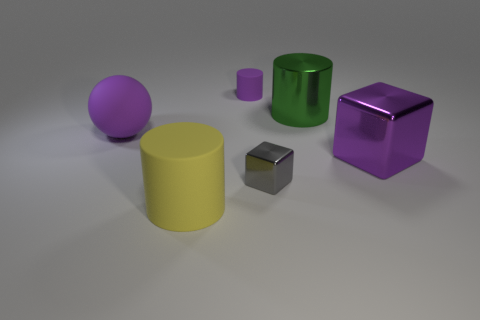Add 3 yellow spheres. How many objects exist? 9 Subtract all cubes. How many objects are left? 4 Subtract all tiny green metallic cylinders. Subtract all large rubber balls. How many objects are left? 5 Add 6 green things. How many green things are left? 7 Add 2 small gray matte cylinders. How many small gray matte cylinders exist? 2 Subtract 1 yellow cylinders. How many objects are left? 5 